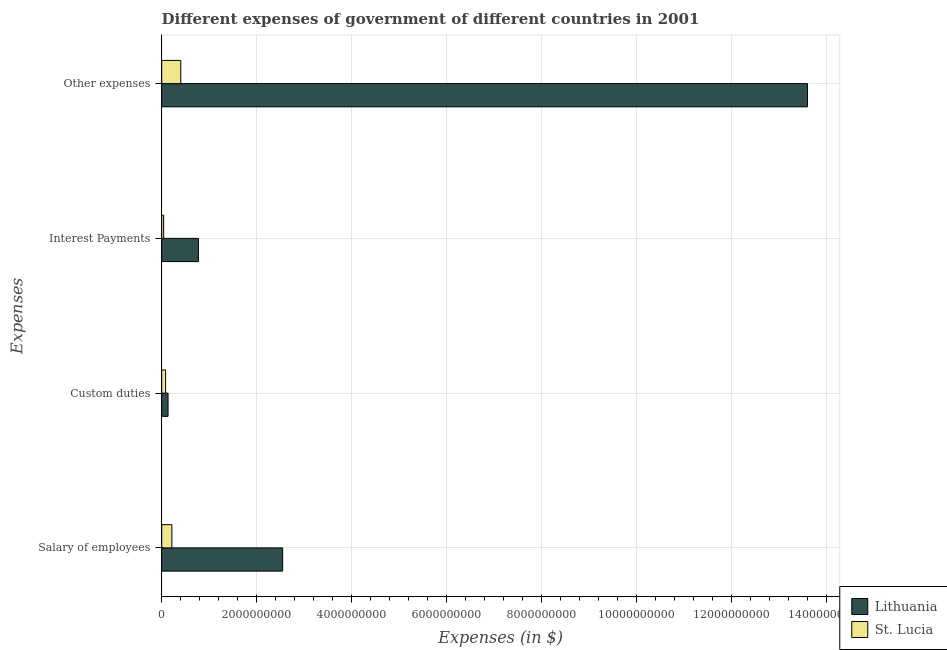Are the number of bars on each tick of the Y-axis equal?
Your answer should be compact. Yes. What is the label of the 2nd group of bars from the top?
Provide a short and direct response. Interest Payments. What is the amount spent on interest payments in Lithuania?
Keep it short and to the point. 7.73e+08. Across all countries, what is the maximum amount spent on custom duties?
Keep it short and to the point. 1.34e+08. Across all countries, what is the minimum amount spent on custom duties?
Keep it short and to the point. 8.25e+07. In which country was the amount spent on interest payments maximum?
Make the answer very short. Lithuania. In which country was the amount spent on other expenses minimum?
Your answer should be compact. St. Lucia. What is the total amount spent on other expenses in the graph?
Provide a succinct answer. 1.40e+1. What is the difference between the amount spent on custom duties in Lithuania and that in St. Lucia?
Provide a short and direct response. 5.13e+07. What is the difference between the amount spent on salary of employees in St. Lucia and the amount spent on other expenses in Lithuania?
Offer a terse response. -1.34e+1. What is the average amount spent on custom duties per country?
Your answer should be very brief. 1.08e+08. What is the difference between the amount spent on salary of employees and amount spent on custom duties in St. Lucia?
Offer a terse response. 1.31e+08. What is the ratio of the amount spent on other expenses in Lithuania to that in St. Lucia?
Give a very brief answer. 33.89. Is the amount spent on custom duties in Lithuania less than that in St. Lucia?
Your answer should be very brief. No. Is the difference between the amount spent on salary of employees in St. Lucia and Lithuania greater than the difference between the amount spent on custom duties in St. Lucia and Lithuania?
Keep it short and to the point. No. What is the difference between the highest and the second highest amount spent on salary of employees?
Your answer should be compact. 2.33e+09. What is the difference between the highest and the lowest amount spent on other expenses?
Offer a very short reply. 1.32e+1. In how many countries, is the amount spent on salary of employees greater than the average amount spent on salary of employees taken over all countries?
Provide a short and direct response. 1. Is it the case that in every country, the sum of the amount spent on salary of employees and amount spent on other expenses is greater than the sum of amount spent on interest payments and amount spent on custom duties?
Your response must be concise. Yes. What does the 2nd bar from the top in Custom duties represents?
Make the answer very short. Lithuania. What does the 2nd bar from the bottom in Salary of employees represents?
Ensure brevity in your answer.  St. Lucia. How many bars are there?
Make the answer very short. 8. How many countries are there in the graph?
Make the answer very short. 2. Does the graph contain grids?
Make the answer very short. Yes. How are the legend labels stacked?
Your response must be concise. Vertical. What is the title of the graph?
Provide a short and direct response. Different expenses of government of different countries in 2001. What is the label or title of the X-axis?
Ensure brevity in your answer.  Expenses (in $). What is the label or title of the Y-axis?
Keep it short and to the point. Expenses. What is the Expenses (in $) of Lithuania in Salary of employees?
Offer a very short reply. 2.55e+09. What is the Expenses (in $) of St. Lucia in Salary of employees?
Your answer should be very brief. 2.14e+08. What is the Expenses (in $) of Lithuania in Custom duties?
Your answer should be very brief. 1.34e+08. What is the Expenses (in $) of St. Lucia in Custom duties?
Your answer should be compact. 8.25e+07. What is the Expenses (in $) of Lithuania in Interest Payments?
Your response must be concise. 7.73e+08. What is the Expenses (in $) in St. Lucia in Interest Payments?
Keep it short and to the point. 4.08e+07. What is the Expenses (in $) in Lithuania in Other expenses?
Your answer should be compact. 1.36e+1. What is the Expenses (in $) of St. Lucia in Other expenses?
Keep it short and to the point. 4.01e+08. Across all Expenses, what is the maximum Expenses (in $) of Lithuania?
Offer a very short reply. 1.36e+1. Across all Expenses, what is the maximum Expenses (in $) of St. Lucia?
Your answer should be compact. 4.01e+08. Across all Expenses, what is the minimum Expenses (in $) of Lithuania?
Keep it short and to the point. 1.34e+08. Across all Expenses, what is the minimum Expenses (in $) in St. Lucia?
Offer a very short reply. 4.08e+07. What is the total Expenses (in $) in Lithuania in the graph?
Offer a very short reply. 1.70e+1. What is the total Expenses (in $) in St. Lucia in the graph?
Your answer should be very brief. 7.38e+08. What is the difference between the Expenses (in $) in Lithuania in Salary of employees and that in Custom duties?
Keep it short and to the point. 2.41e+09. What is the difference between the Expenses (in $) in St. Lucia in Salary of employees and that in Custom duties?
Provide a short and direct response. 1.31e+08. What is the difference between the Expenses (in $) of Lithuania in Salary of employees and that in Interest Payments?
Give a very brief answer. 1.77e+09. What is the difference between the Expenses (in $) of St. Lucia in Salary of employees and that in Interest Payments?
Offer a terse response. 1.73e+08. What is the difference between the Expenses (in $) in Lithuania in Salary of employees and that in Other expenses?
Offer a terse response. -1.10e+1. What is the difference between the Expenses (in $) in St. Lucia in Salary of employees and that in Other expenses?
Make the answer very short. -1.88e+08. What is the difference between the Expenses (in $) in Lithuania in Custom duties and that in Interest Payments?
Offer a terse response. -6.40e+08. What is the difference between the Expenses (in $) in St. Lucia in Custom duties and that in Interest Payments?
Your answer should be very brief. 4.17e+07. What is the difference between the Expenses (in $) of Lithuania in Custom duties and that in Other expenses?
Give a very brief answer. -1.35e+1. What is the difference between the Expenses (in $) in St. Lucia in Custom duties and that in Other expenses?
Your response must be concise. -3.18e+08. What is the difference between the Expenses (in $) of Lithuania in Interest Payments and that in Other expenses?
Offer a terse response. -1.28e+1. What is the difference between the Expenses (in $) in St. Lucia in Interest Payments and that in Other expenses?
Offer a very short reply. -3.60e+08. What is the difference between the Expenses (in $) in Lithuania in Salary of employees and the Expenses (in $) in St. Lucia in Custom duties?
Give a very brief answer. 2.46e+09. What is the difference between the Expenses (in $) in Lithuania in Salary of employees and the Expenses (in $) in St. Lucia in Interest Payments?
Your answer should be very brief. 2.50e+09. What is the difference between the Expenses (in $) of Lithuania in Salary of employees and the Expenses (in $) of St. Lucia in Other expenses?
Provide a succinct answer. 2.14e+09. What is the difference between the Expenses (in $) in Lithuania in Custom duties and the Expenses (in $) in St. Lucia in Interest Payments?
Provide a short and direct response. 9.30e+07. What is the difference between the Expenses (in $) in Lithuania in Custom duties and the Expenses (in $) in St. Lucia in Other expenses?
Keep it short and to the point. -2.67e+08. What is the difference between the Expenses (in $) in Lithuania in Interest Payments and the Expenses (in $) in St. Lucia in Other expenses?
Provide a short and direct response. 3.72e+08. What is the average Expenses (in $) in Lithuania per Expenses?
Keep it short and to the point. 4.26e+09. What is the average Expenses (in $) in St. Lucia per Expenses?
Provide a succinct answer. 1.84e+08. What is the difference between the Expenses (in $) in Lithuania and Expenses (in $) in St. Lucia in Salary of employees?
Offer a terse response. 2.33e+09. What is the difference between the Expenses (in $) in Lithuania and Expenses (in $) in St. Lucia in Custom duties?
Make the answer very short. 5.13e+07. What is the difference between the Expenses (in $) of Lithuania and Expenses (in $) of St. Lucia in Interest Payments?
Your response must be concise. 7.32e+08. What is the difference between the Expenses (in $) in Lithuania and Expenses (in $) in St. Lucia in Other expenses?
Offer a very short reply. 1.32e+1. What is the ratio of the Expenses (in $) of Lithuania in Salary of employees to that in Custom duties?
Ensure brevity in your answer.  19.02. What is the ratio of the Expenses (in $) of St. Lucia in Salary of employees to that in Custom duties?
Your answer should be very brief. 2.59. What is the ratio of the Expenses (in $) in Lithuania in Salary of employees to that in Interest Payments?
Keep it short and to the point. 3.29. What is the ratio of the Expenses (in $) in St. Lucia in Salary of employees to that in Interest Payments?
Your response must be concise. 5.23. What is the ratio of the Expenses (in $) in Lithuania in Salary of employees to that in Other expenses?
Provide a short and direct response. 0.19. What is the ratio of the Expenses (in $) of St. Lucia in Salary of employees to that in Other expenses?
Provide a short and direct response. 0.53. What is the ratio of the Expenses (in $) of Lithuania in Custom duties to that in Interest Payments?
Provide a succinct answer. 0.17. What is the ratio of the Expenses (in $) of St. Lucia in Custom duties to that in Interest Payments?
Provide a succinct answer. 2.02. What is the ratio of the Expenses (in $) of Lithuania in Custom duties to that in Other expenses?
Your answer should be compact. 0.01. What is the ratio of the Expenses (in $) in St. Lucia in Custom duties to that in Other expenses?
Your answer should be very brief. 0.21. What is the ratio of the Expenses (in $) in Lithuania in Interest Payments to that in Other expenses?
Give a very brief answer. 0.06. What is the ratio of the Expenses (in $) of St. Lucia in Interest Payments to that in Other expenses?
Ensure brevity in your answer.  0.1. What is the difference between the highest and the second highest Expenses (in $) of Lithuania?
Offer a terse response. 1.10e+1. What is the difference between the highest and the second highest Expenses (in $) in St. Lucia?
Give a very brief answer. 1.88e+08. What is the difference between the highest and the lowest Expenses (in $) of Lithuania?
Give a very brief answer. 1.35e+1. What is the difference between the highest and the lowest Expenses (in $) in St. Lucia?
Offer a terse response. 3.60e+08. 